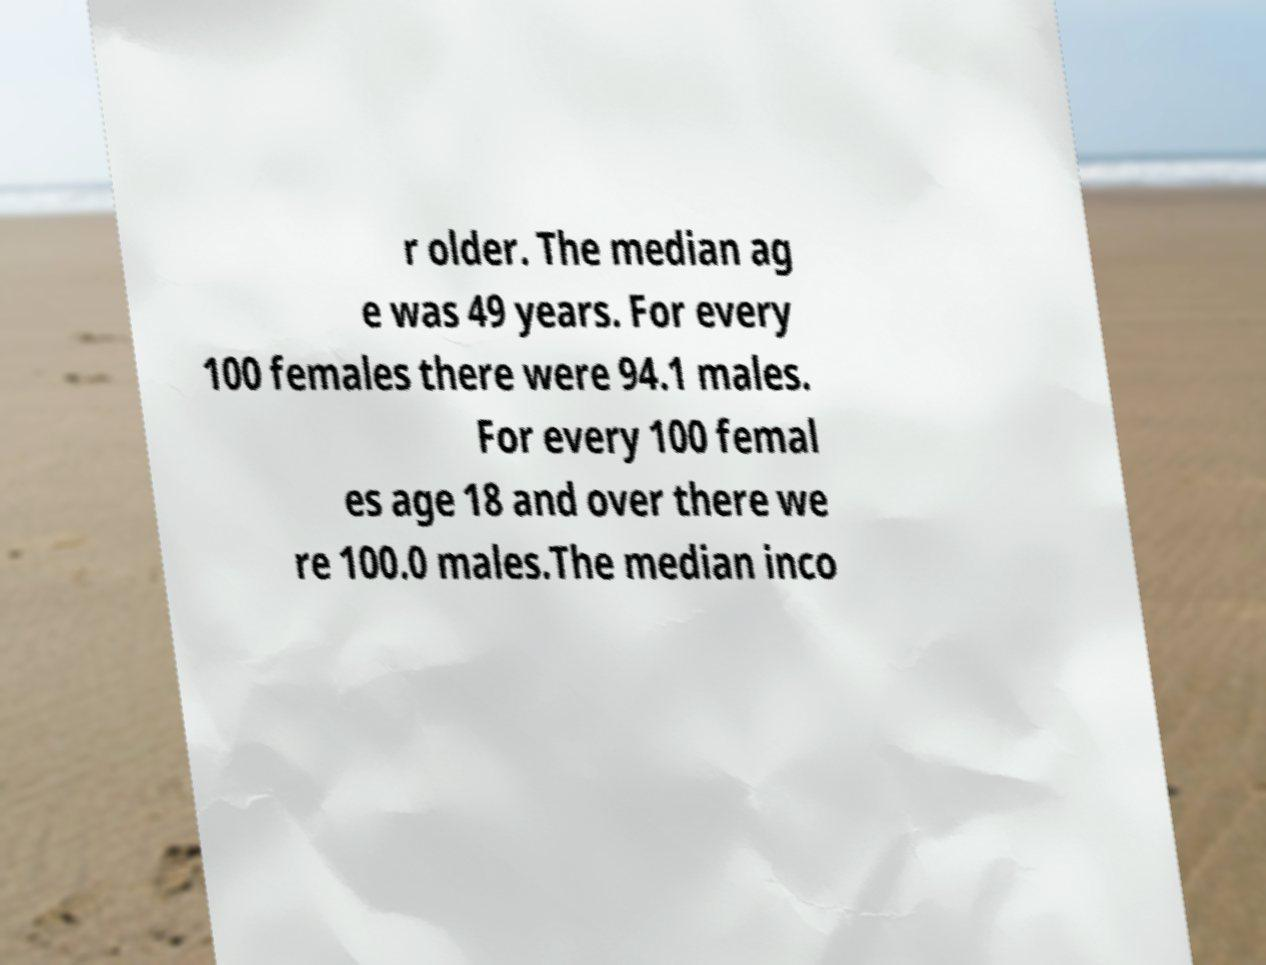Can you accurately transcribe the text from the provided image for me? r older. The median ag e was 49 years. For every 100 females there were 94.1 males. For every 100 femal es age 18 and over there we re 100.0 males.The median inco 